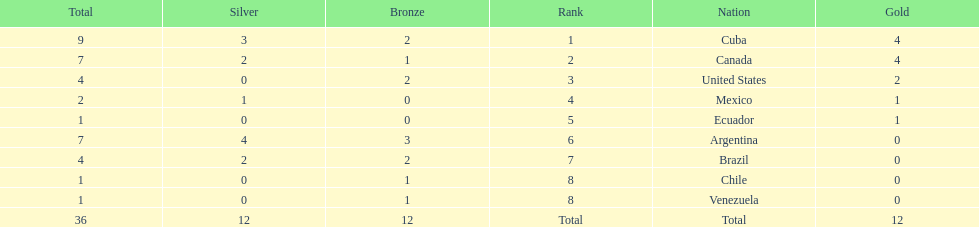How many total medals did brazil received? 4. 